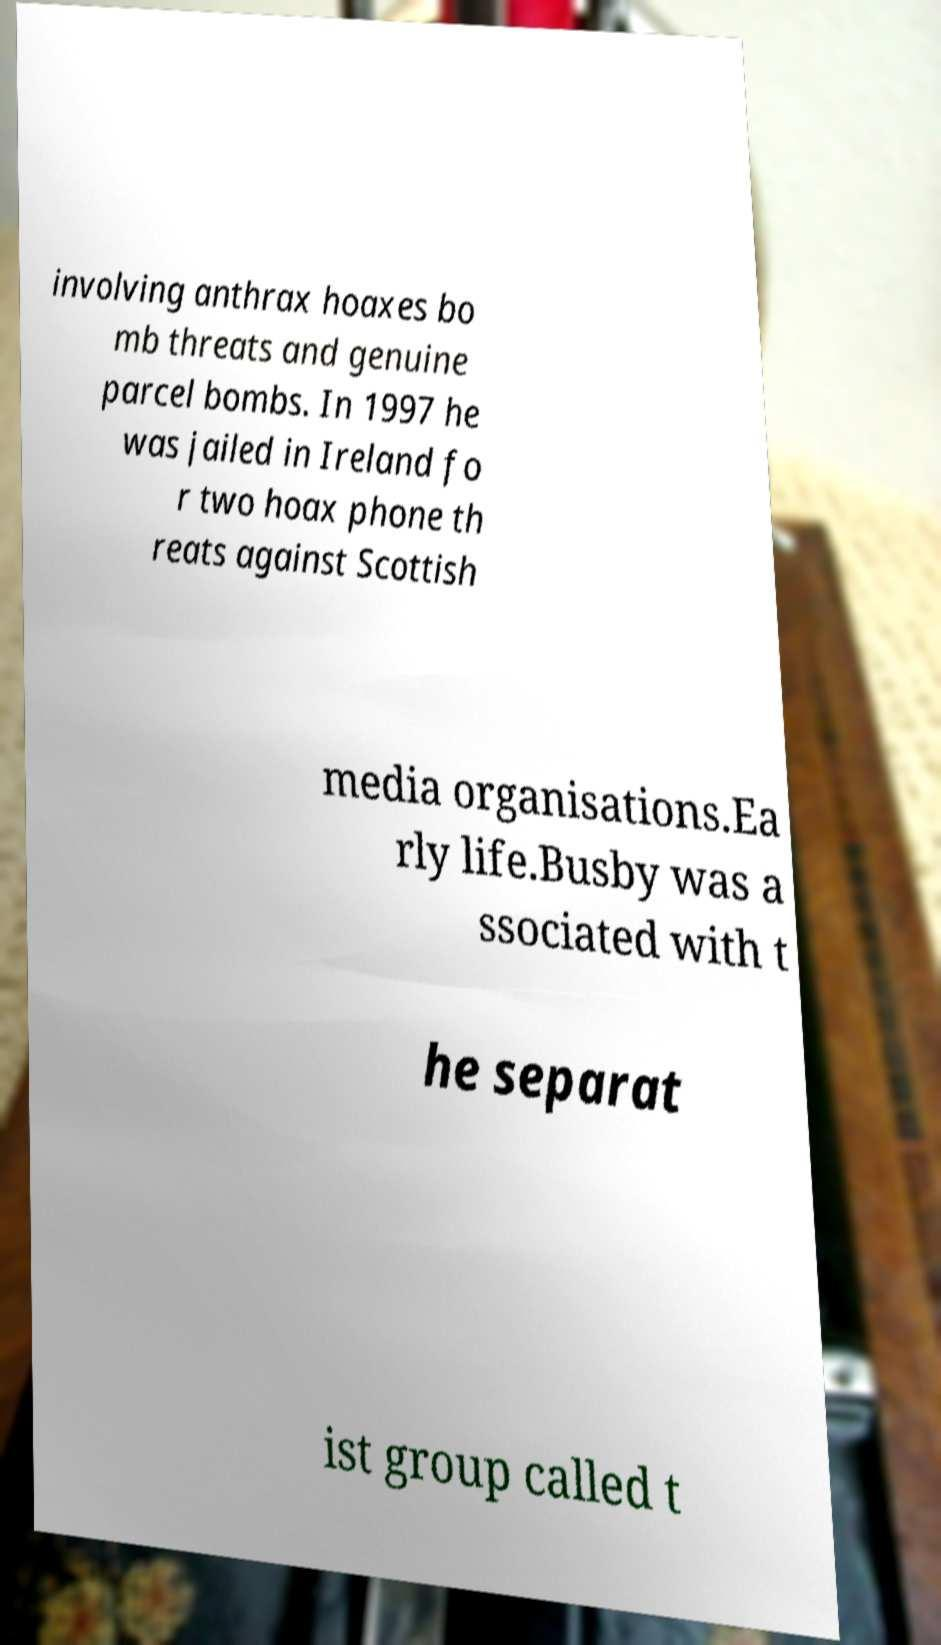What messages or text are displayed in this image? I need them in a readable, typed format. involving anthrax hoaxes bo mb threats and genuine parcel bombs. In 1997 he was jailed in Ireland fo r two hoax phone th reats against Scottish media organisations.Ea rly life.Busby was a ssociated with t he separat ist group called t 